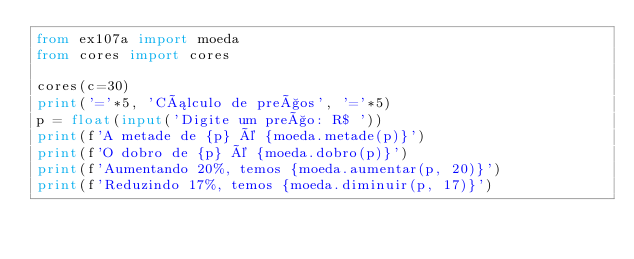Convert code to text. <code><loc_0><loc_0><loc_500><loc_500><_Python_>from ex107a import moeda
from cores import cores

cores(c=30)
print('='*5, 'Cálculo de preços', '='*5)
p = float(input('Digite um preço: R$ '))
print(f'A metade de {p} é {moeda.metade(p)}')
print(f'O dobro de {p} é {moeda.dobro(p)}')
print(f'Aumentando 20%, temos {moeda.aumentar(p, 20)}')
print(f'Reduzindo 17%, temos {moeda.diminuir(p, 17)}')
</code> 